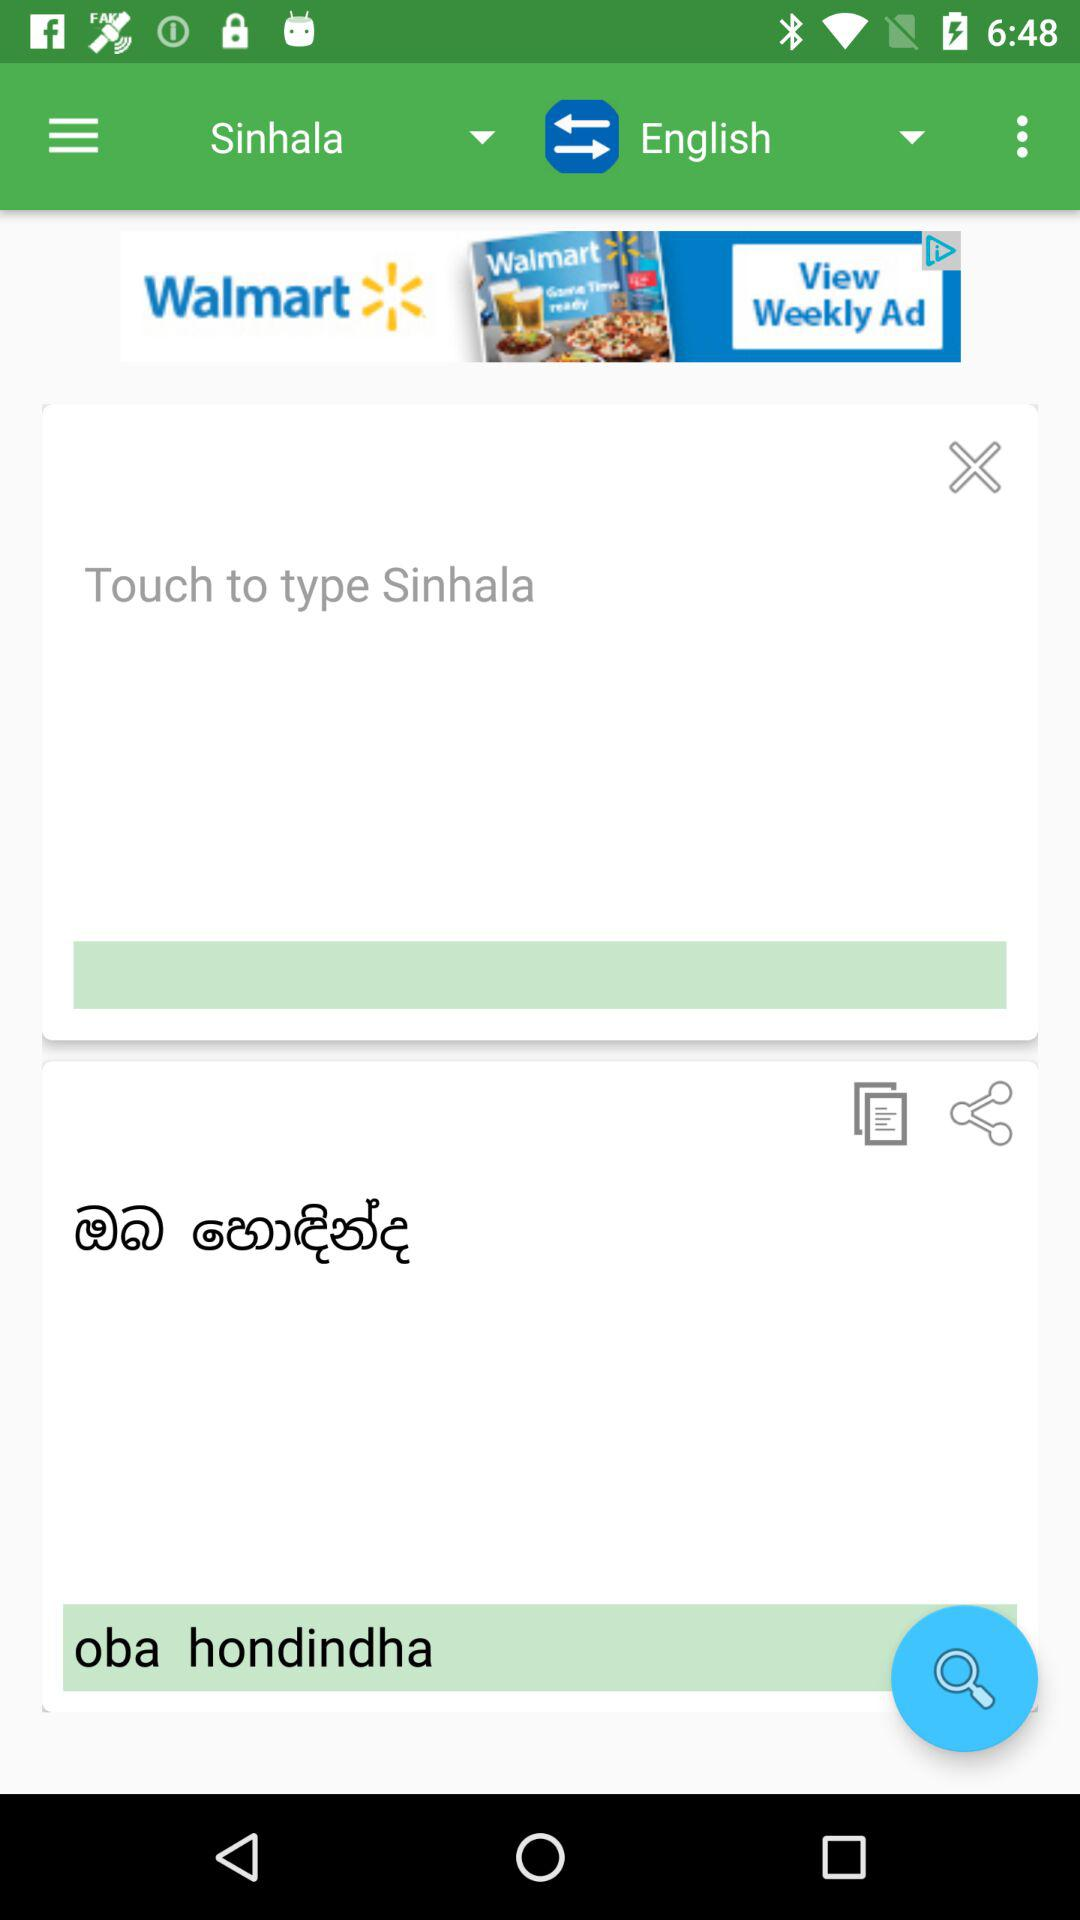Which language is translated into which? The Sinhala language is translated into English. 